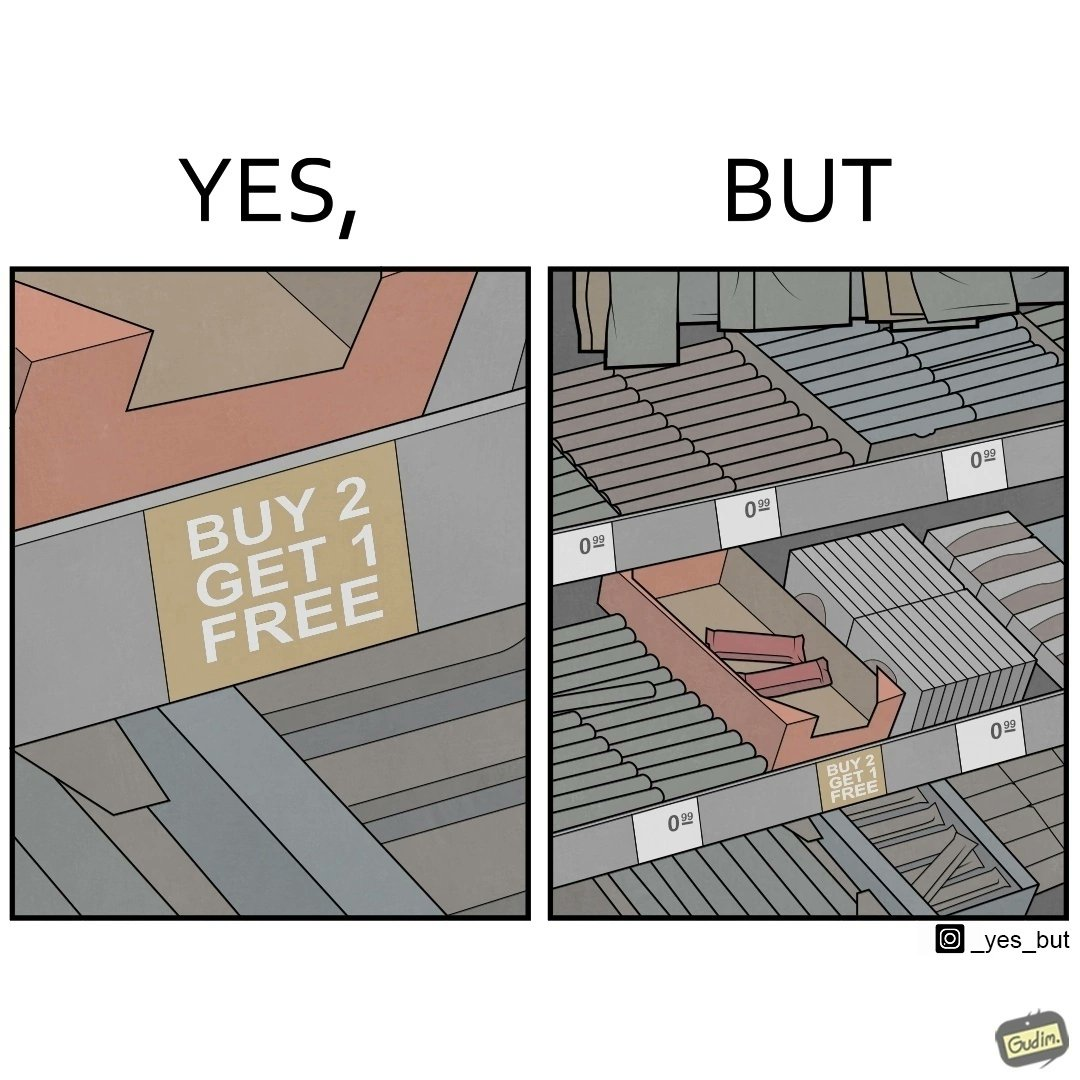Is this a satirical image? Yes, this image is satirical. 